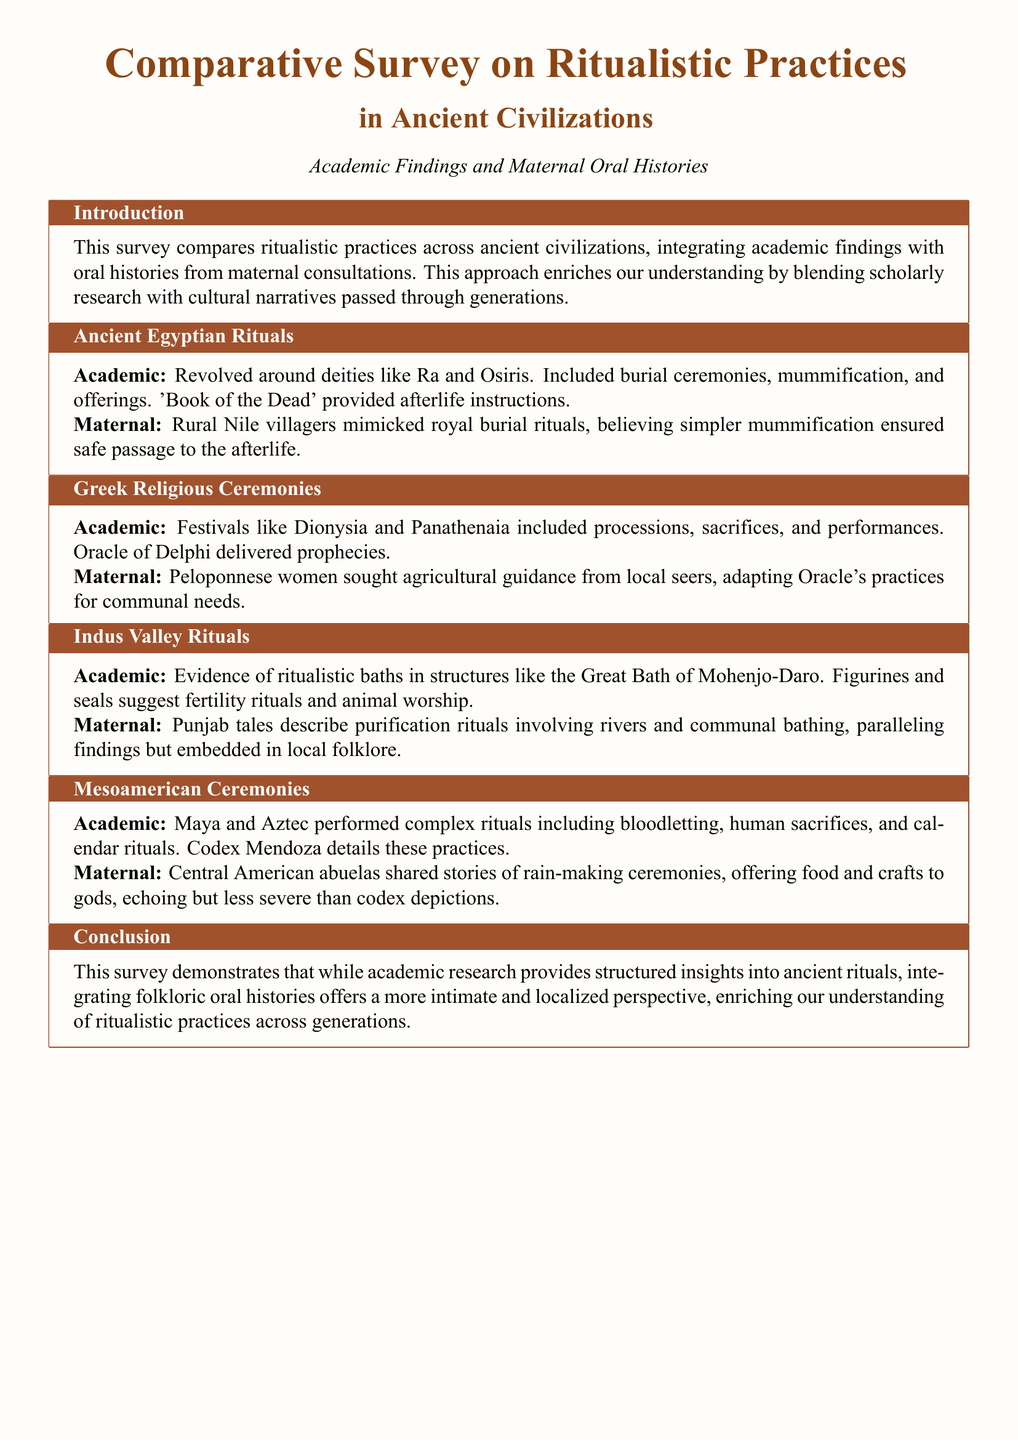what is the title of the document? The title is presented prominently at the beginning of the document and describes the content of the survey.
Answer: Comparative Survey on Ritualistic Practices in Ancient Civilizations: Academic Findings and Maternal Oral Histories which civilization's rituals are discussed in relation to mummification? The section on Ancient Egyptian Rituals specifies practices involving mummification and burial ceremonies.
Answer: Ancient Egyptians what type of rituals were highlighted in the Indus Valley section? The Indus Valley section describes ritualistic baths and fertility rituals based on academic findings.
Answer: Ritualistic baths who provided prophecies in Greek Religious Ceremonies? The document mentions the Oracle of Delphi as the source of prophecies in Greek rituals.
Answer: Oracle of Delphi what practice did Central American abuelas share stories about? The maternal section about Mesoamerican Ceremonies describes rain-making ceremonies as shared by local narrators.
Answer: Rain-making ceremonies how did the maternal findings in Ancient Egyptian rituals compare to academic findings? The document notes that rural Nile villagers mimicked royal burial rituals based on the academic insights regarding mummification.
Answer: Simpler mummification what is the primary purpose of the survey as stated in the introduction? The introduction outlines the survey's goal of blending academic findings with maternal oral histories for a richer understanding.
Answer: To enrich understanding which civilization's communal bathing rituals are described in Punjab tales? The Indus Valley section mentions communal bathing rituals being similar to those described in Punjab tales, linking the two cultures.
Answer: Indus Valley 